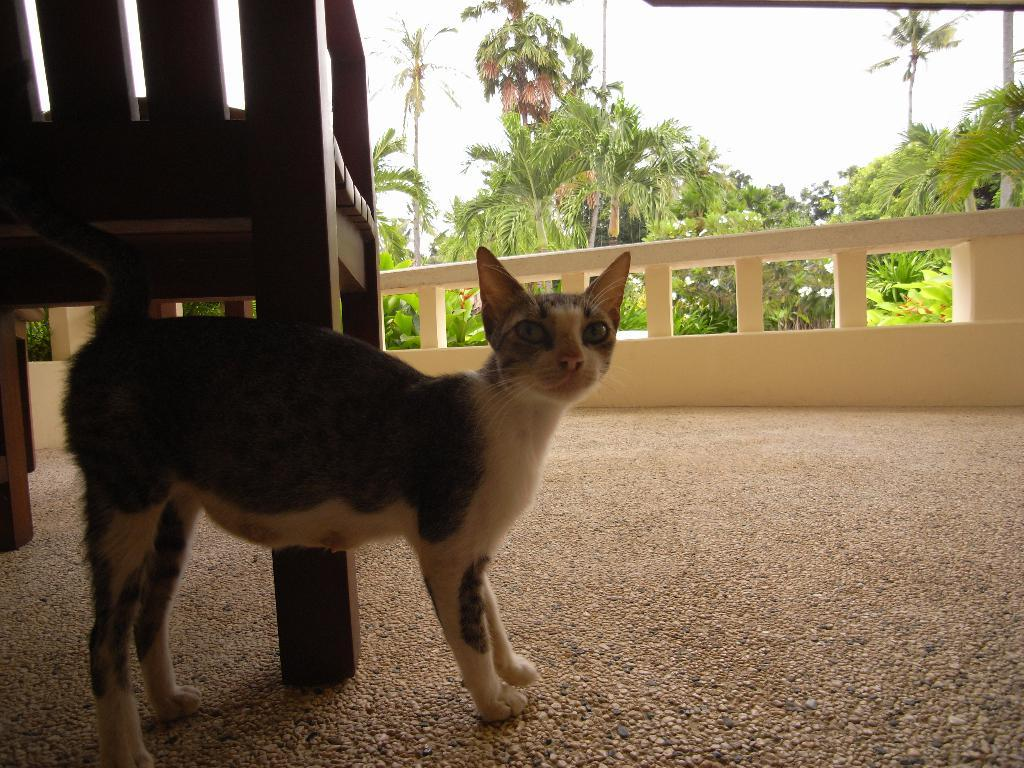What is located in the foreground of the picture? There is a chair and a cat in the foreground of the picture. What is the surface beneath the chair and cat? There is a floor in the foreground of the picture. What can be seen in the center of the picture? There is railing in the center of the picture. What type of vegetation is visible in the background of the picture? There are palm trees and trees in the background of the picture. What is visible in the sky in the background of the picture? The sky is visible in the background of the picture. How many spiders are crawling on the railing in the image? There are no spiders present in the image. What type of curve can be seen in the palm trees in the image? There are no curves mentioned in the image; the palm trees are described as being in the background. 